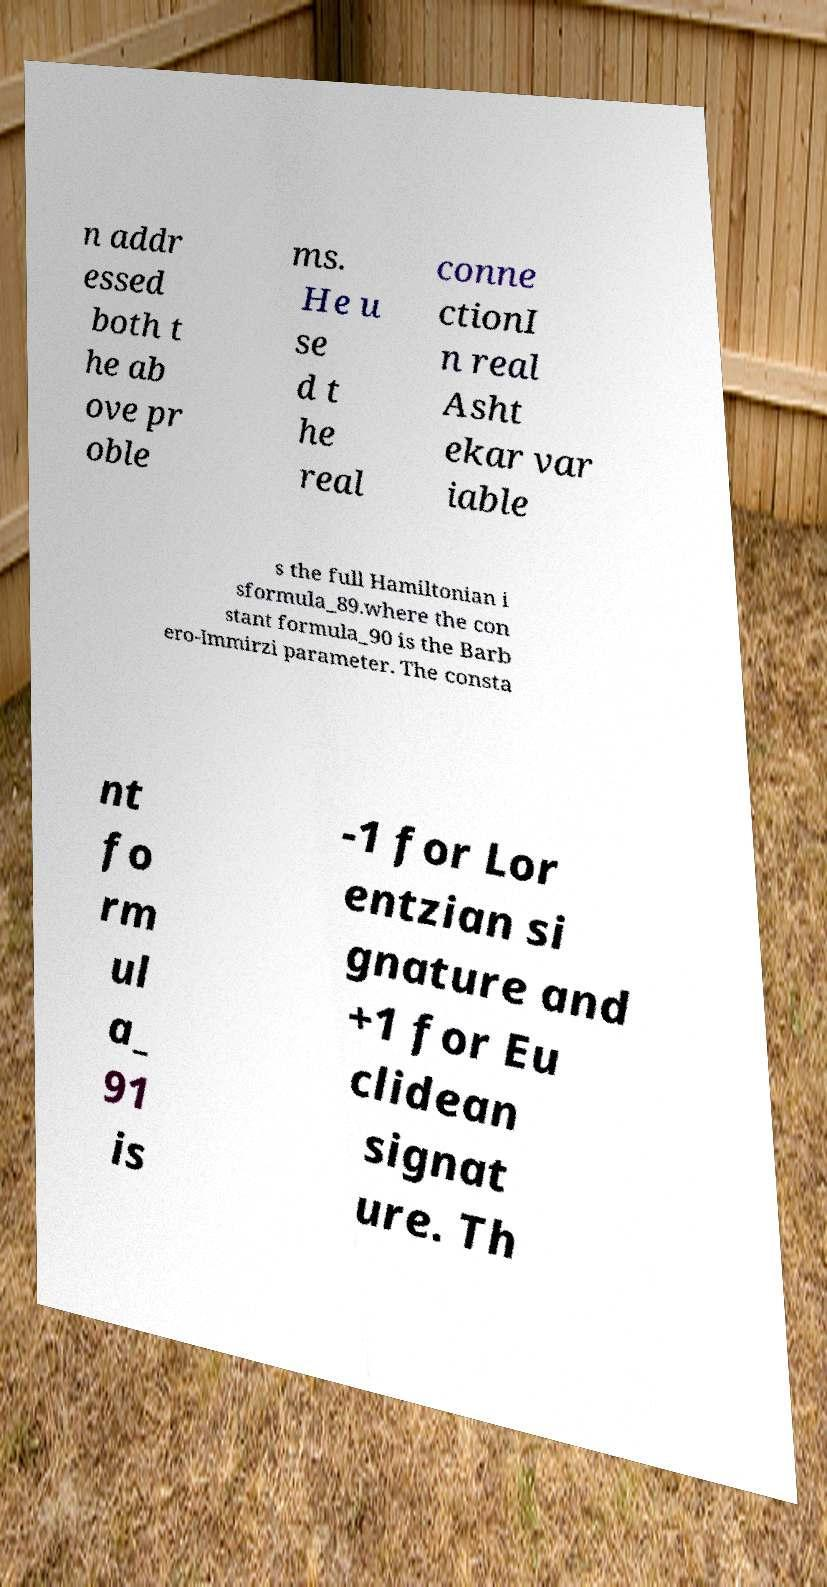Please read and relay the text visible in this image. What does it say? n addr essed both t he ab ove pr oble ms. He u se d t he real conne ctionI n real Asht ekar var iable s the full Hamiltonian i sformula_89.where the con stant formula_90 is the Barb ero-Immirzi parameter. The consta nt fo rm ul a_ 91 is -1 for Lor entzian si gnature and +1 for Eu clidean signat ure. Th 